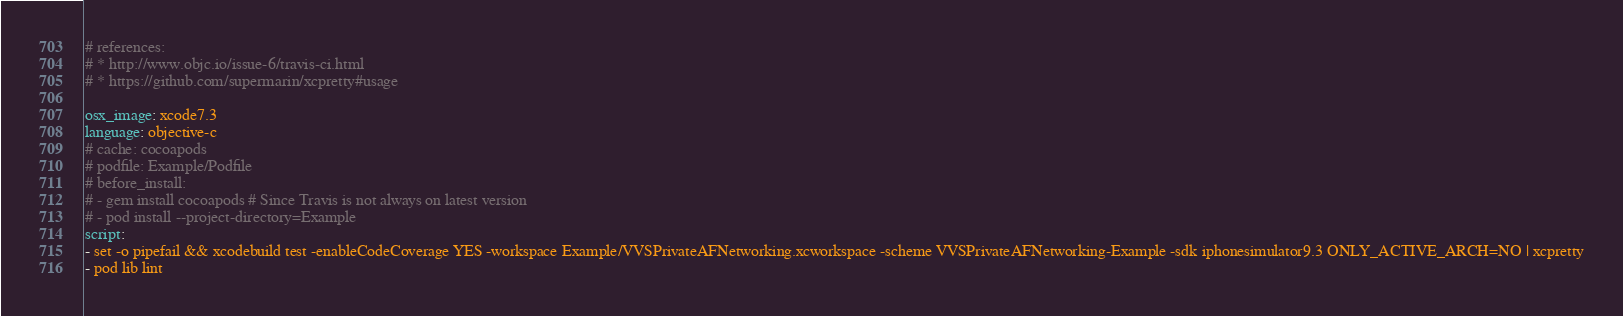Convert code to text. <code><loc_0><loc_0><loc_500><loc_500><_YAML_># references:
# * http://www.objc.io/issue-6/travis-ci.html
# * https://github.com/supermarin/xcpretty#usage

osx_image: xcode7.3
language: objective-c
# cache: cocoapods
# podfile: Example/Podfile
# before_install:
# - gem install cocoapods # Since Travis is not always on latest version
# - pod install --project-directory=Example
script:
- set -o pipefail && xcodebuild test -enableCodeCoverage YES -workspace Example/VVSPrivateAFNetworking.xcworkspace -scheme VVSPrivateAFNetworking-Example -sdk iphonesimulator9.3 ONLY_ACTIVE_ARCH=NO | xcpretty
- pod lib lint
</code> 